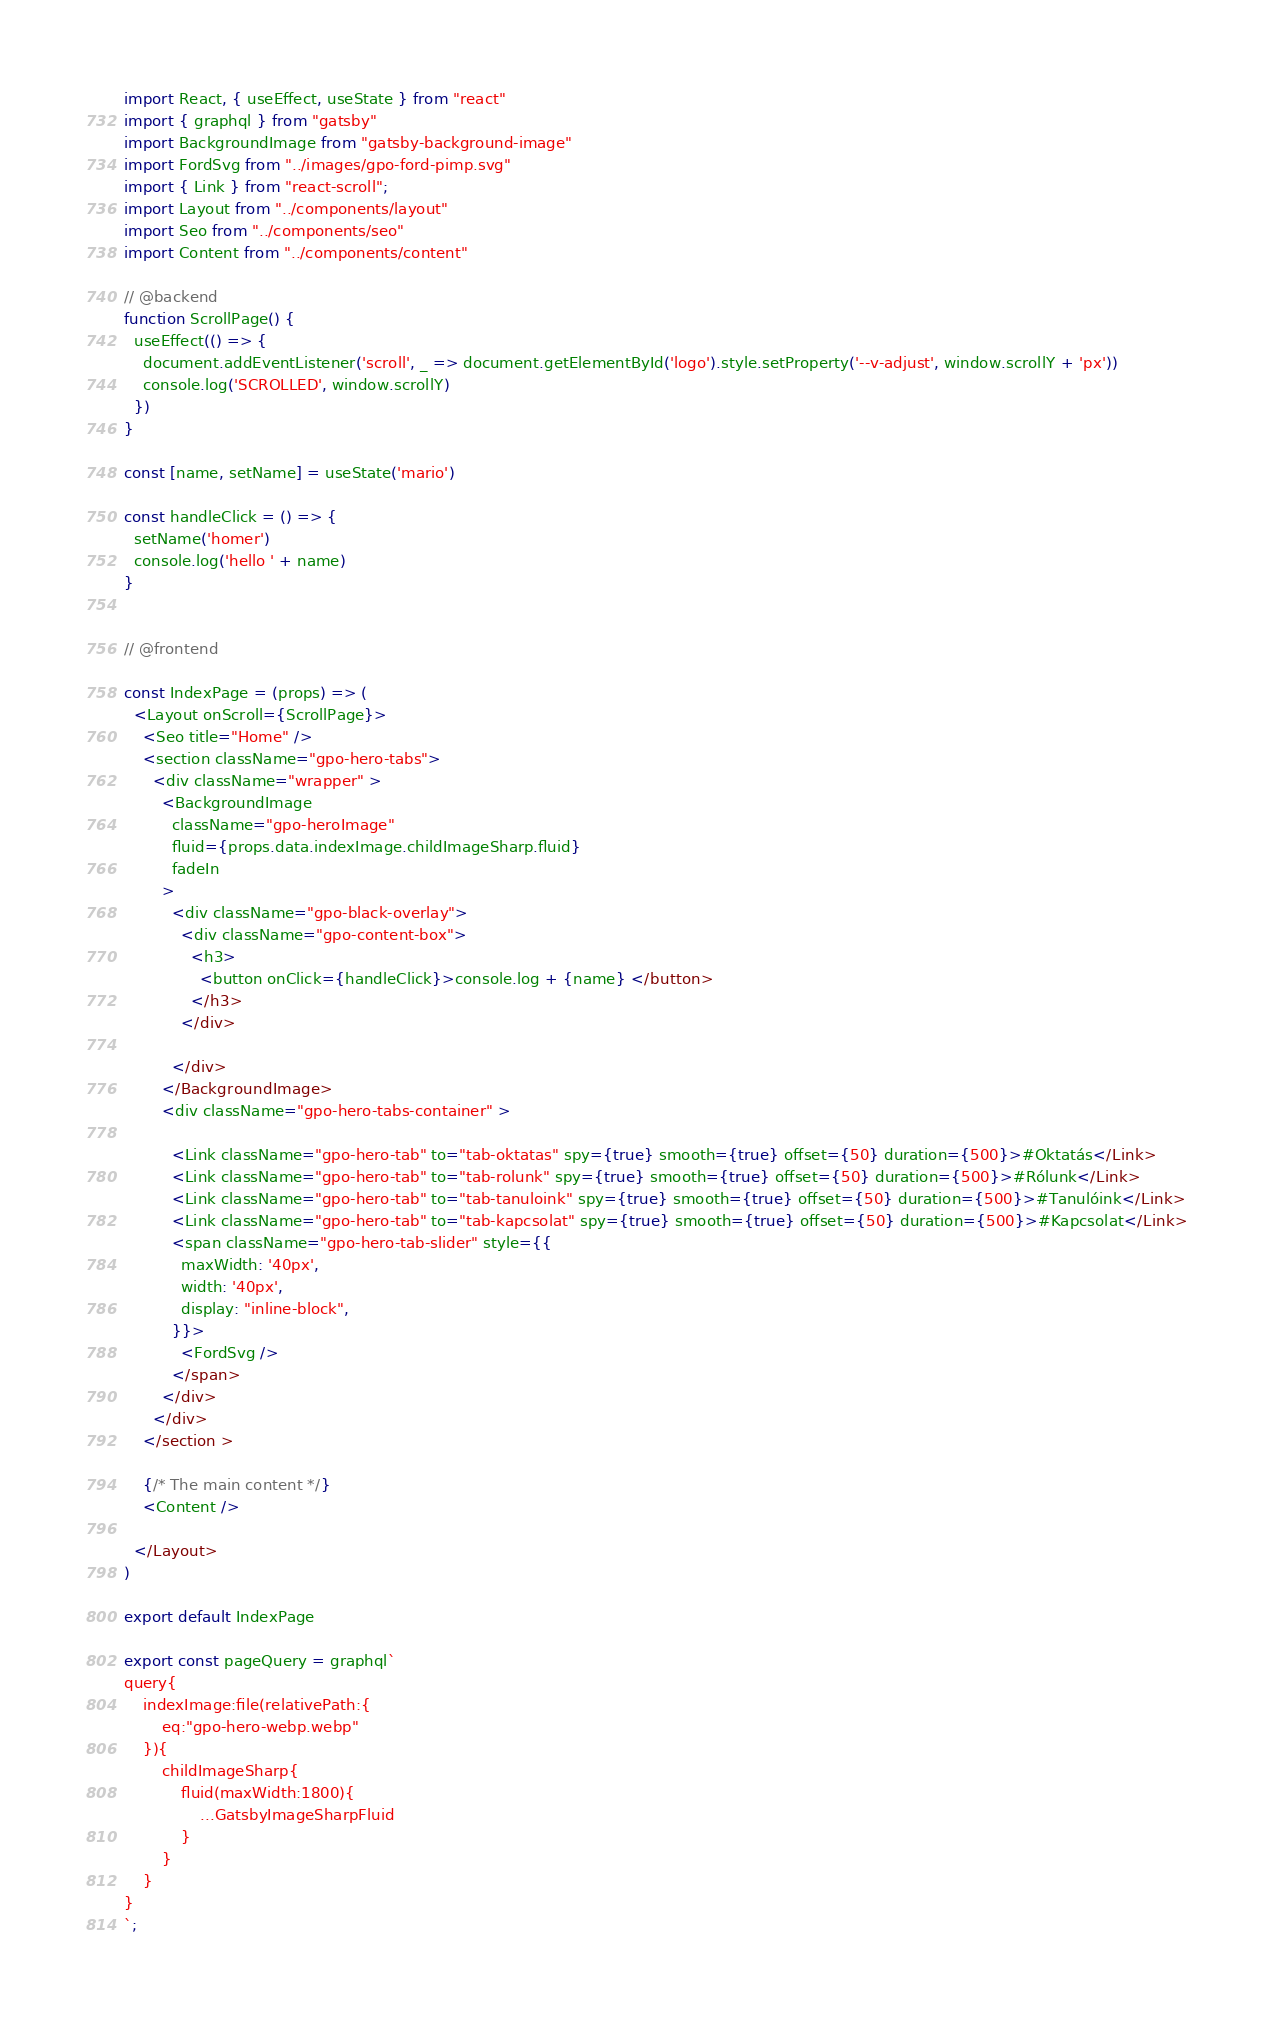Convert code to text. <code><loc_0><loc_0><loc_500><loc_500><_JavaScript_>import React, { useEffect, useState } from "react"
import { graphql } from "gatsby"
import BackgroundImage from "gatsby-background-image"
import FordSvg from "../images/gpo-ford-pimp.svg"
import { Link } from "react-scroll";
import Layout from "../components/layout"
import Seo from "../components/seo"
import Content from "../components/content"

// @backend
function ScrollPage() {
  useEffect(() => {
    document.addEventListener('scroll', _ => document.getElementById('logo').style.setProperty('--v-adjust', window.scrollY + 'px'))
    console.log('SCROLLED', window.scrollY)
  })
}

const [name, setName] = useState('mario')

const handleClick = () => {
  setName('homer')
  console.log('hello ' + name)
}


// @frontend

const IndexPage = (props) => (
  <Layout onScroll={ScrollPage}>
    <Seo title="Home" />
    <section className="gpo-hero-tabs">
      <div className="wrapper" >
        <BackgroundImage
          className="gpo-heroImage"
          fluid={props.data.indexImage.childImageSharp.fluid}
          fadeIn
        >
          <div className="gpo-black-overlay">
            <div className="gpo-content-box">
              <h3>
                <button onClick={handleClick}>console.log + {name} </button>
              </h3>
            </div>

          </div>
        </BackgroundImage>
        <div className="gpo-hero-tabs-container" >

          <Link className="gpo-hero-tab" to="tab-oktatas" spy={true} smooth={true} offset={50} duration={500}>#Oktatás</Link>
          <Link className="gpo-hero-tab" to="tab-rolunk" spy={true} smooth={true} offset={50} duration={500}>#Rólunk</Link>
          <Link className="gpo-hero-tab" to="tab-tanuloink" spy={true} smooth={true} offset={50} duration={500}>#Tanulóink</Link>
          <Link className="gpo-hero-tab" to="tab-kapcsolat" spy={true} smooth={true} offset={50} duration={500}>#Kapcsolat</Link>
          <span className="gpo-hero-tab-slider" style={{
            maxWidth: '40px',
            width: '40px',
            display: "inline-block",
          }}>
            <FordSvg />
          </span>
        </div>
      </div>
    </section >

    {/* The main content */}
    <Content />

  </Layout>
)

export default IndexPage

export const pageQuery = graphql`
query{
    indexImage:file(relativePath:{
        eq:"gpo-hero-webp.webp"
    }){
        childImageSharp{
            fluid(maxWidth:1800){
                ...GatsbyImageSharpFluid
            }
        }
    }
}
`;</code> 